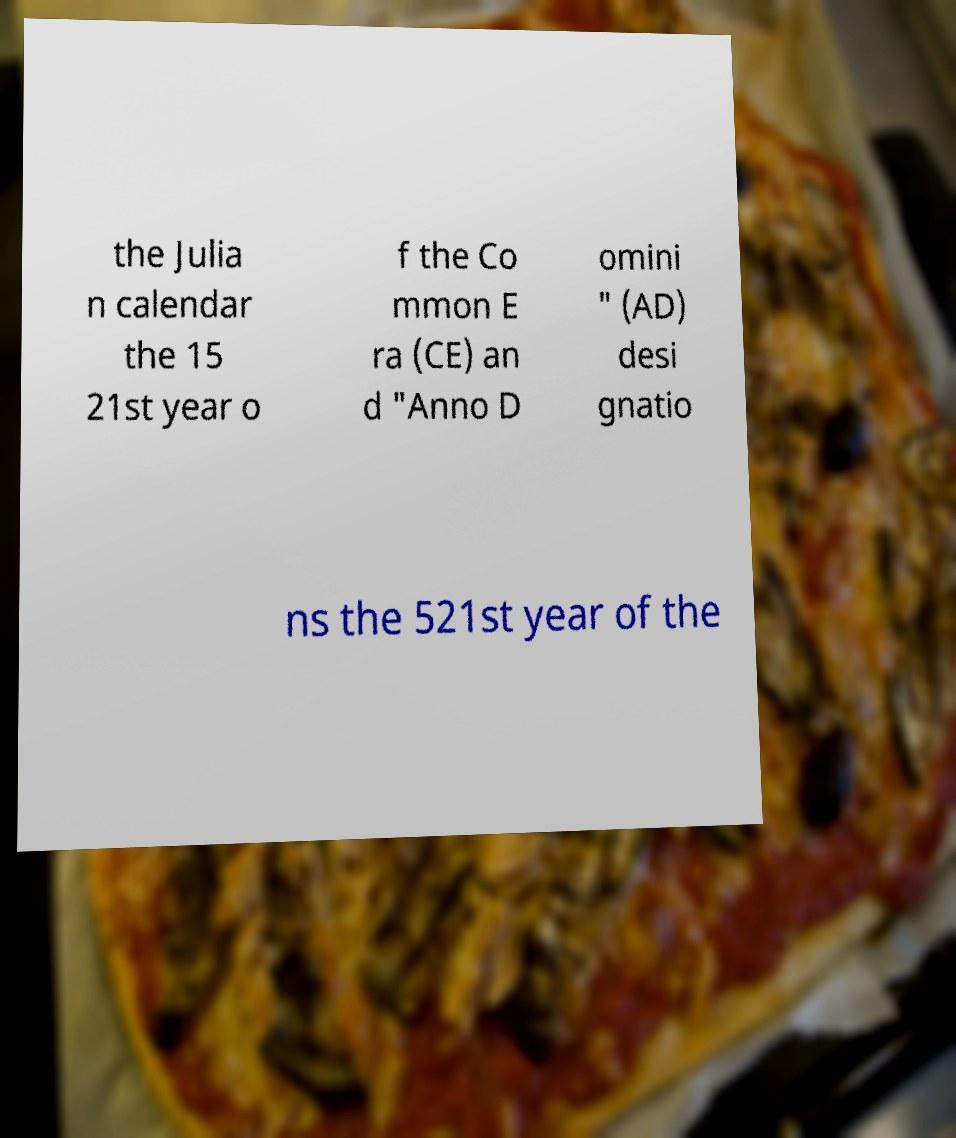Can you accurately transcribe the text from the provided image for me? the Julia n calendar the 15 21st year o f the Co mmon E ra (CE) an d "Anno D omini " (AD) desi gnatio ns the 521st year of the 